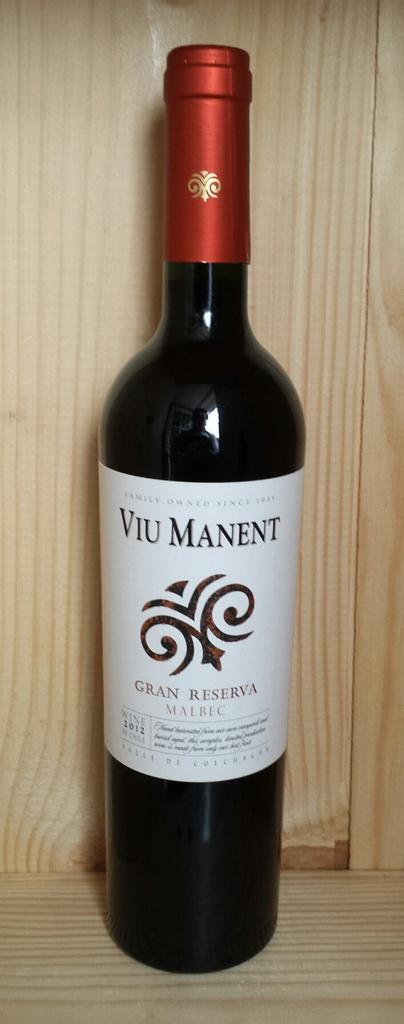<image>
Summarize the visual content of the image. A bottle of Malbec stands inside a wooden container. 